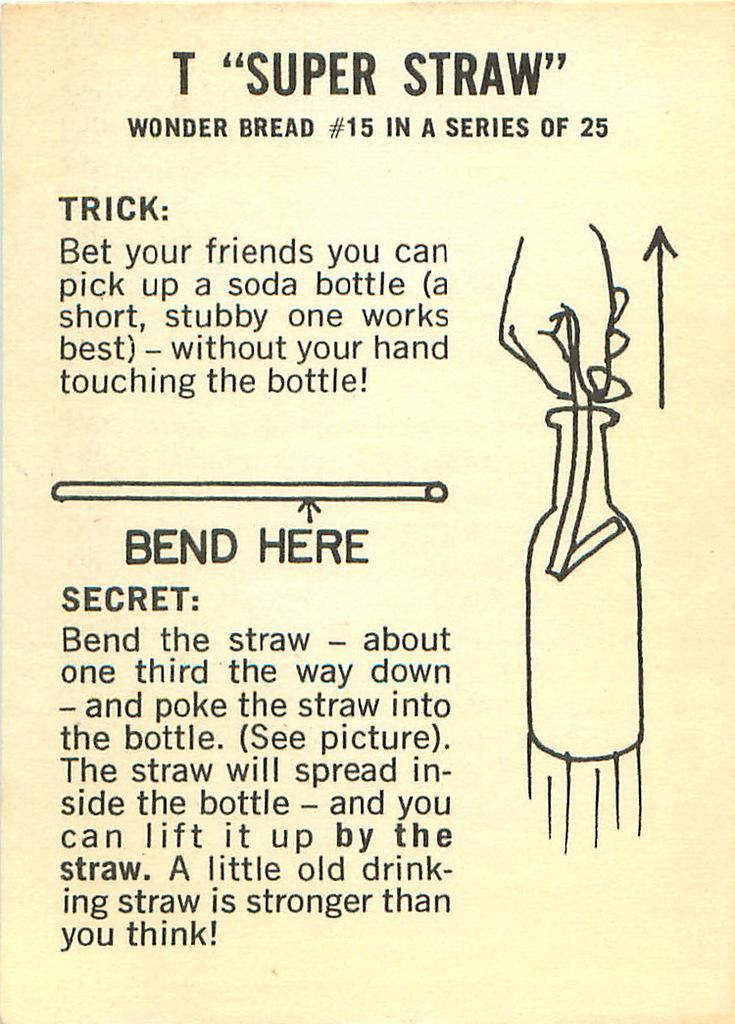<image>
Describe the image concisely. A super straw magic trick is explained on this flyer which involves lifting a bottle with a straw. 